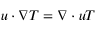<formula> <loc_0><loc_0><loc_500><loc_500>u \cdot \nabla T = \nabla \cdot u T</formula> 